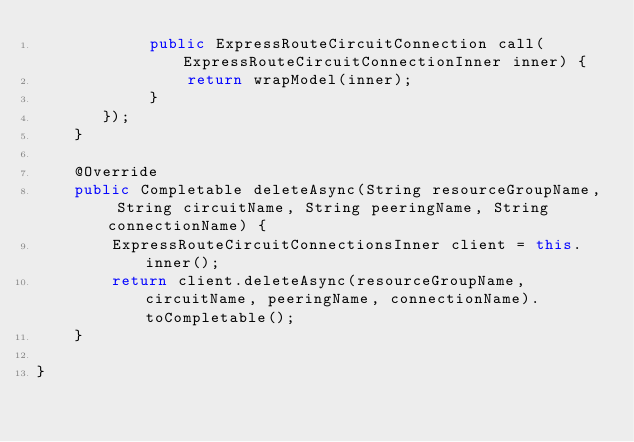Convert code to text. <code><loc_0><loc_0><loc_500><loc_500><_Java_>            public ExpressRouteCircuitConnection call(ExpressRouteCircuitConnectionInner inner) {
                return wrapModel(inner);
            }
       });
    }

    @Override
    public Completable deleteAsync(String resourceGroupName, String circuitName, String peeringName, String connectionName) {
        ExpressRouteCircuitConnectionsInner client = this.inner();
        return client.deleteAsync(resourceGroupName, circuitName, peeringName, connectionName).toCompletable();
    }

}
</code> 